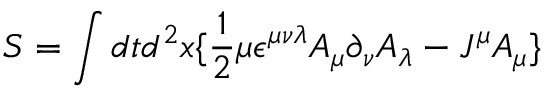Convert formula to latex. <formula><loc_0><loc_0><loc_500><loc_500>S = \int d t d ^ { 2 } x \{ \frac { 1 } { 2 } \mu \epsilon ^ { \mu \nu \lambda } A _ { \mu } \partial _ { \nu } A _ { \lambda } - J ^ { \mu } A _ { \mu } \}</formula> 